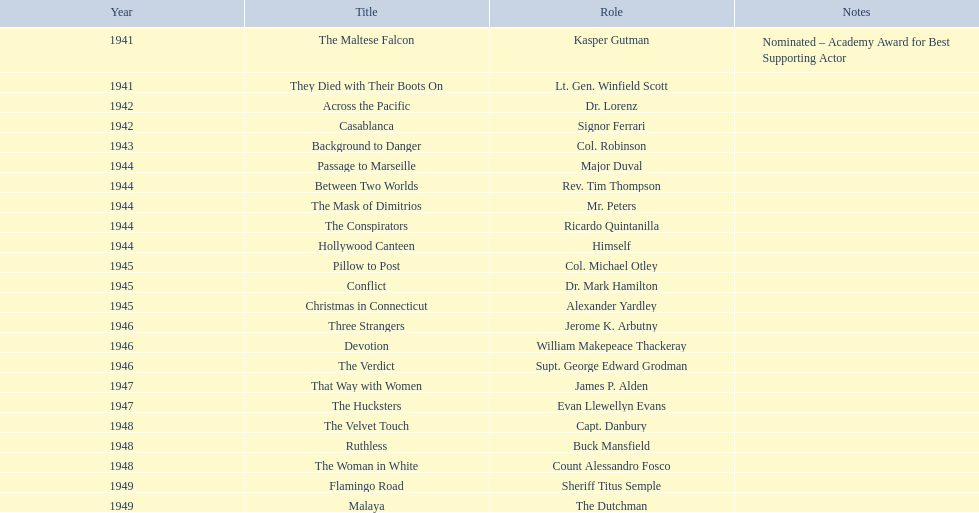Which movies are being referred to? The Maltese Falcon, They Died with Their Boots On, Across the Pacific, Casablanca, Background to Danger, Passage to Marseille, Between Two Worlds, The Mask of Dimitrios, The Conspirators, Hollywood Canteen, Pillow to Post, Conflict, Christmas in Connecticut, Three Strangers, Devotion, The Verdict, That Way with Women, The Hucksters, The Velvet Touch, Ruthless, The Woman in White, Flamingo Road, Malaya. Out of those, for which did he receive an oscar nomination? The Maltese Falcon. 